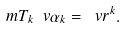Convert formula to latex. <formula><loc_0><loc_0><loc_500><loc_500>\ m { T } _ { k } \ v { \alpha } _ { k } = \ v { r } ^ { k } .</formula> 